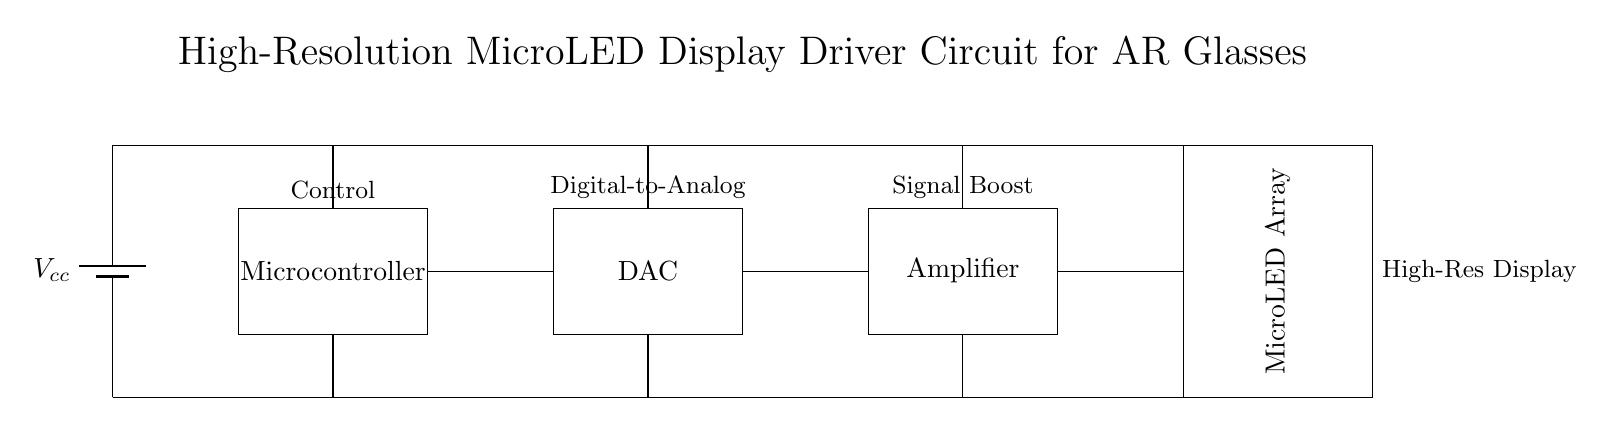What is the primary function of the microcontroller in this circuit? The microcontroller is responsible for control functions, receiving inputs to manage the display operation, and coordinating the signal flow within the circuit.
Answer: Control What component comes after the digital-to-analog converter? The amplifier follows the digital-to-analog converter, boosting the signal before it reaches the microLED array for better display performance.
Answer: Amplifier How many power connections are present in the circuit? There are four power connections in total, each supplying the respective components with voltage from the source.
Answer: Four What is the main output of this circuit? The main output of the circuit is the high-resolution microLED display, which renders visual information for augmented reality applications.
Answer: High-Res Display Why is it necessary to include an amplifier in the display driver circuit? An amplifier is included to enhance the signal strength from the DAC to ensure the microLED array receives sufficient power for bright and clear images, improving overall display quality.
Answer: Signal Boost 